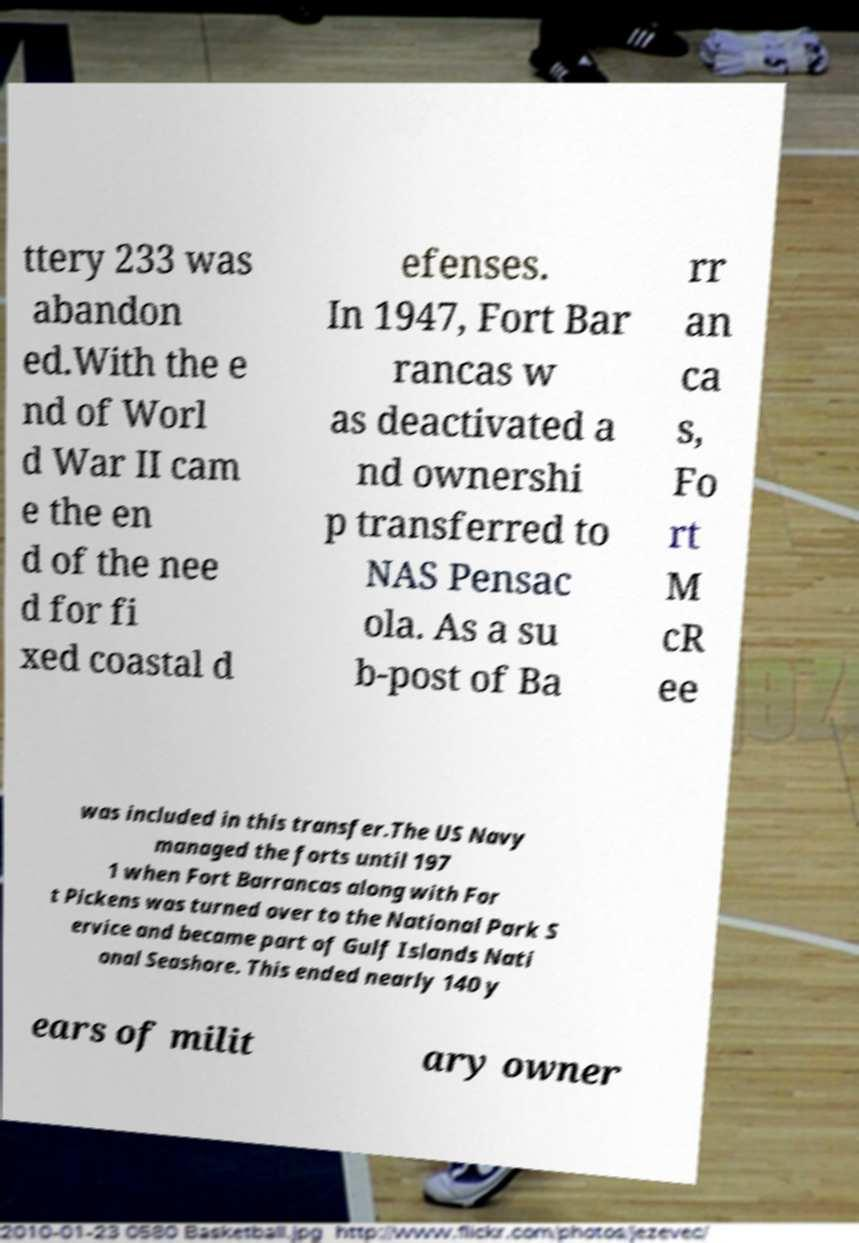Can you accurately transcribe the text from the provided image for me? ttery 233 was abandon ed.With the e nd of Worl d War II cam e the en d of the nee d for fi xed coastal d efenses. In 1947, Fort Bar rancas w as deactivated a nd ownershi p transferred to NAS Pensac ola. As a su b-post of Ba rr an ca s, Fo rt M cR ee was included in this transfer.The US Navy managed the forts until 197 1 when Fort Barrancas along with For t Pickens was turned over to the National Park S ervice and became part of Gulf Islands Nati onal Seashore. This ended nearly 140 y ears of milit ary owner 